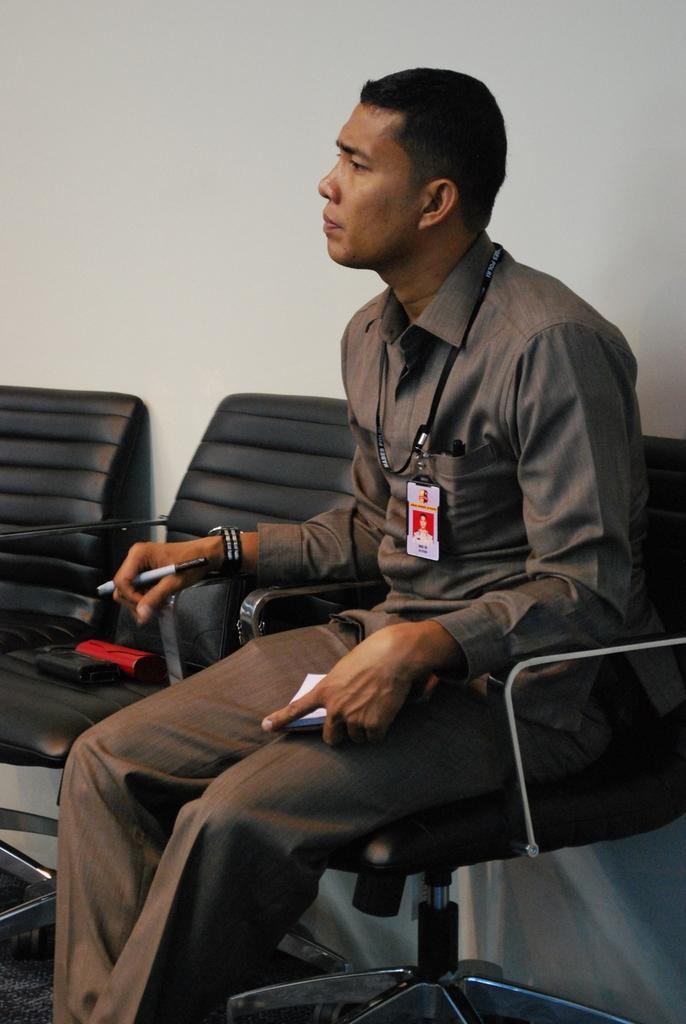Describe this image in one or two sentences. In this image we can see this person wearing shirt and identity card is holding a pen and book and sitting on the chair. Here we can see two more chairs and the wall in the background. 